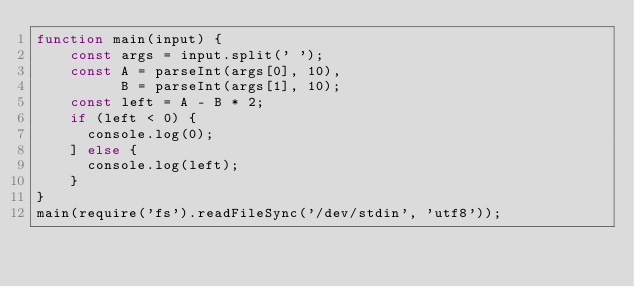Convert code to text. <code><loc_0><loc_0><loc_500><loc_500><_JavaScript_>function main(input) {
    const args = input.split(' ');
    const A = parseInt(args[0], 10),
          B = parseInt(args[1], 10);
    const left = A - B * 2;
    if (left < 0) {
      console.log(0);
    ] else {
      console.log(left);
    }
}
main(require('fs').readFileSync('/dev/stdin', 'utf8'));</code> 